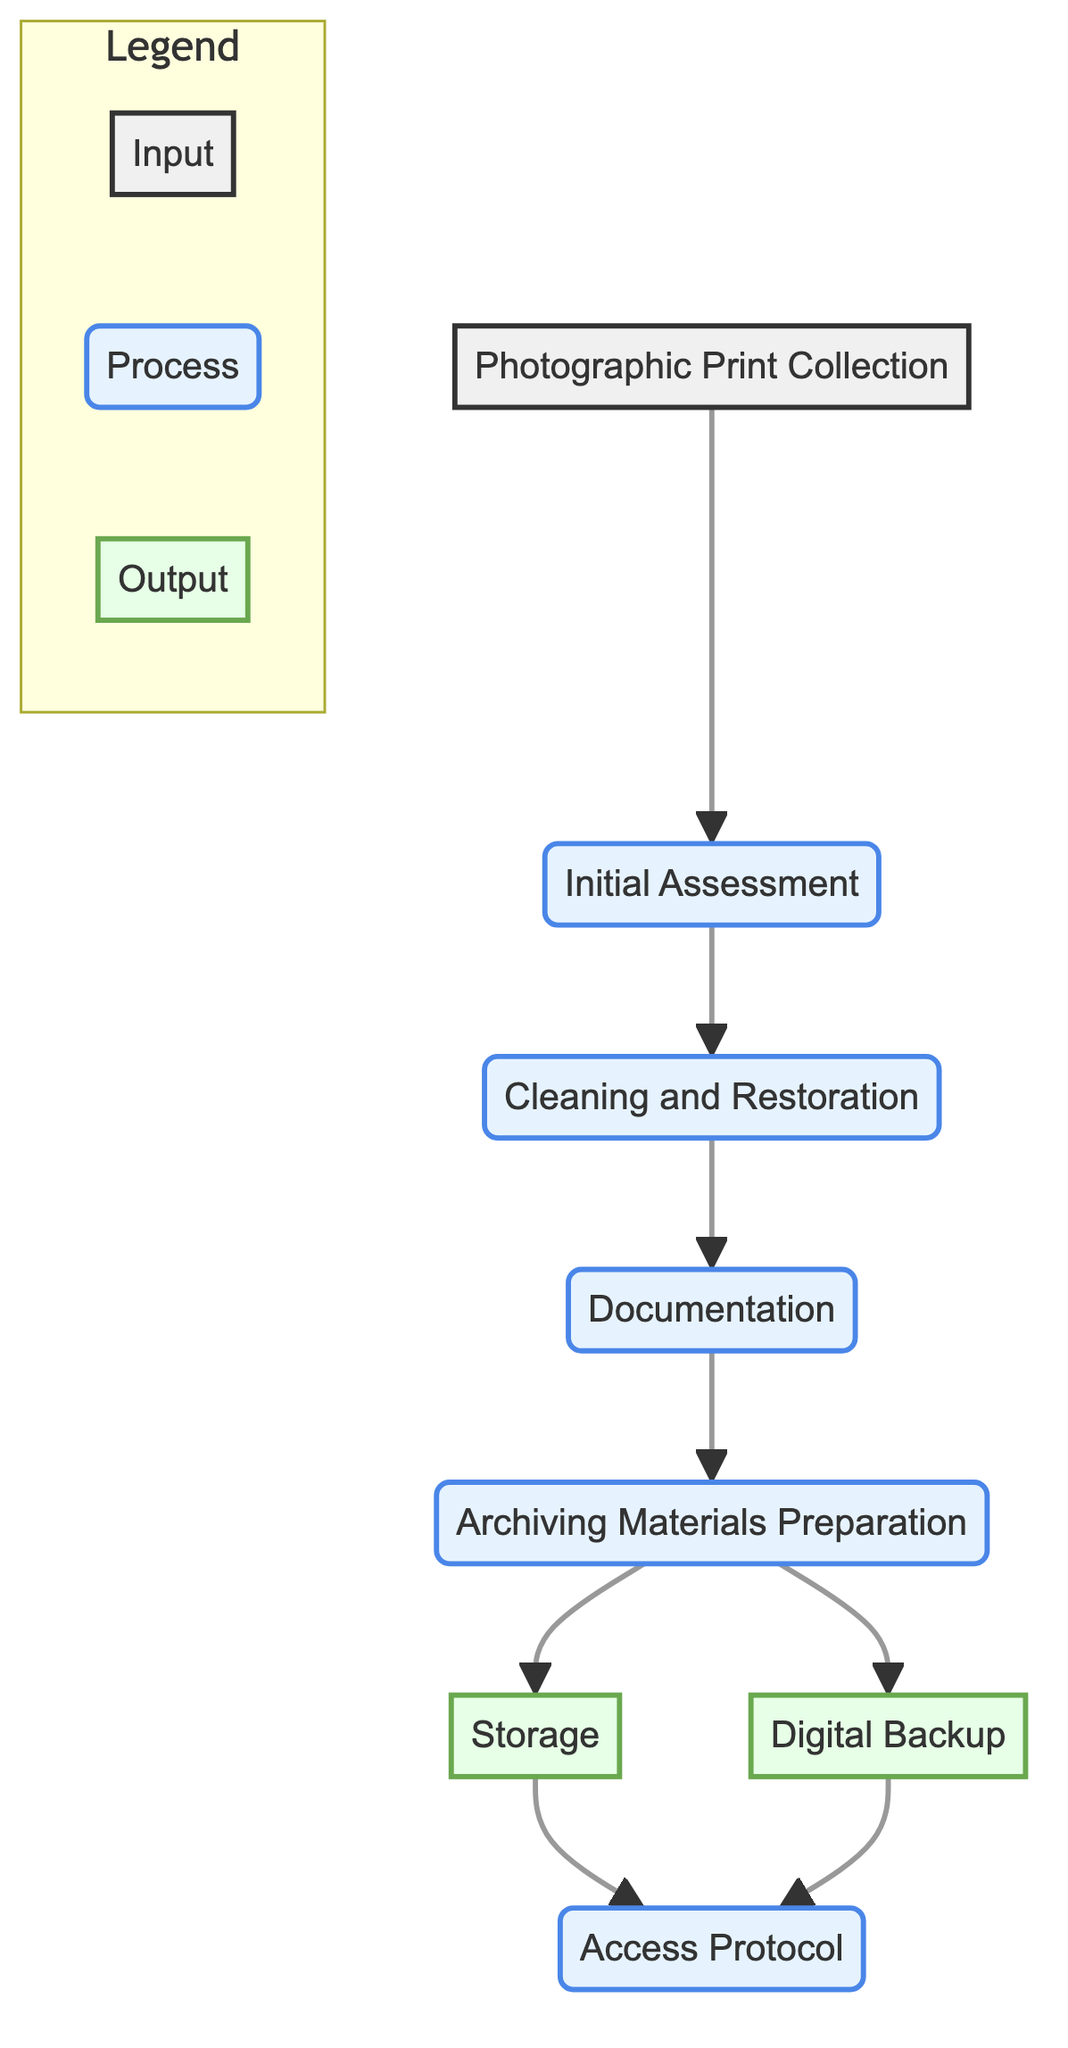What is the input of this workflow? The input of this workflow is the first node in the diagram, which represents the collection of photographic prints that will undergo processing. This node states "Photographic Print Collection" and is labeled as the input element.
Answer: Photographic Print Collection How many processes are involved in this workflow? By observing the nodes connected by arrows leading from the input to the outputs, we can count the process nodes: Initial Assessment, Cleaning and Restoration, Documentation, and Archiving Materials Preparation. This totals four distinct processes.
Answer: 4 What are the outputs of this flowchart? The outputs are the final results of the workflow represented by the last nodes following the processes. In this case, they are "Storage" and "Digital Backup," which are both labeled as outputs.
Answer: Storage and Digital Backup Which process comes immediately after Cleaning and Restoration? The order of processes in the diagram establishes that after "Cleaning and Restoration," the next step is "Documentation," which follows directly as the subsequent node linked by an arrow.
Answer: Documentation What are the connections from Archiving Materials Preparation? Archiving Materials Preparation connects to two output nodes: "Storage" and "Digital Backup." This highlights its role in preparing both physical and digital preservation methods for the prints completing the workflow.
Answer: Storage and Digital Backup Is there a process for establishing access protocols? Yes, the diagram includes the node labeled "Access Protocol," which indicates a dedicated process established for guidelines around viewing and handling the photographic prints by students or researchers.
Answer: Yes What is the main purpose of the Cleaning and Restoration process? The Cleaning and Restoration process is primarily focused on the care of each print by removing dust and deciding on any necessary restoration. This purpose is directly stated in the description associated with that process.
Answer: Careful cleaning What does the documentation process involve? The documentation process entails recording specific details about each print, including its title, date, and any relevant history, as depicted by the description of the Documentation process in the diagram.
Answer: Record details How many outputs derive from the Archiving Materials Preparation step? The Archiving Materials Preparation leads to two distinct outputs within the workflow, which are "Storage" and "Digital Backup." This indicates multiple methods of preserving the prints post-preparation.
Answer: 2 